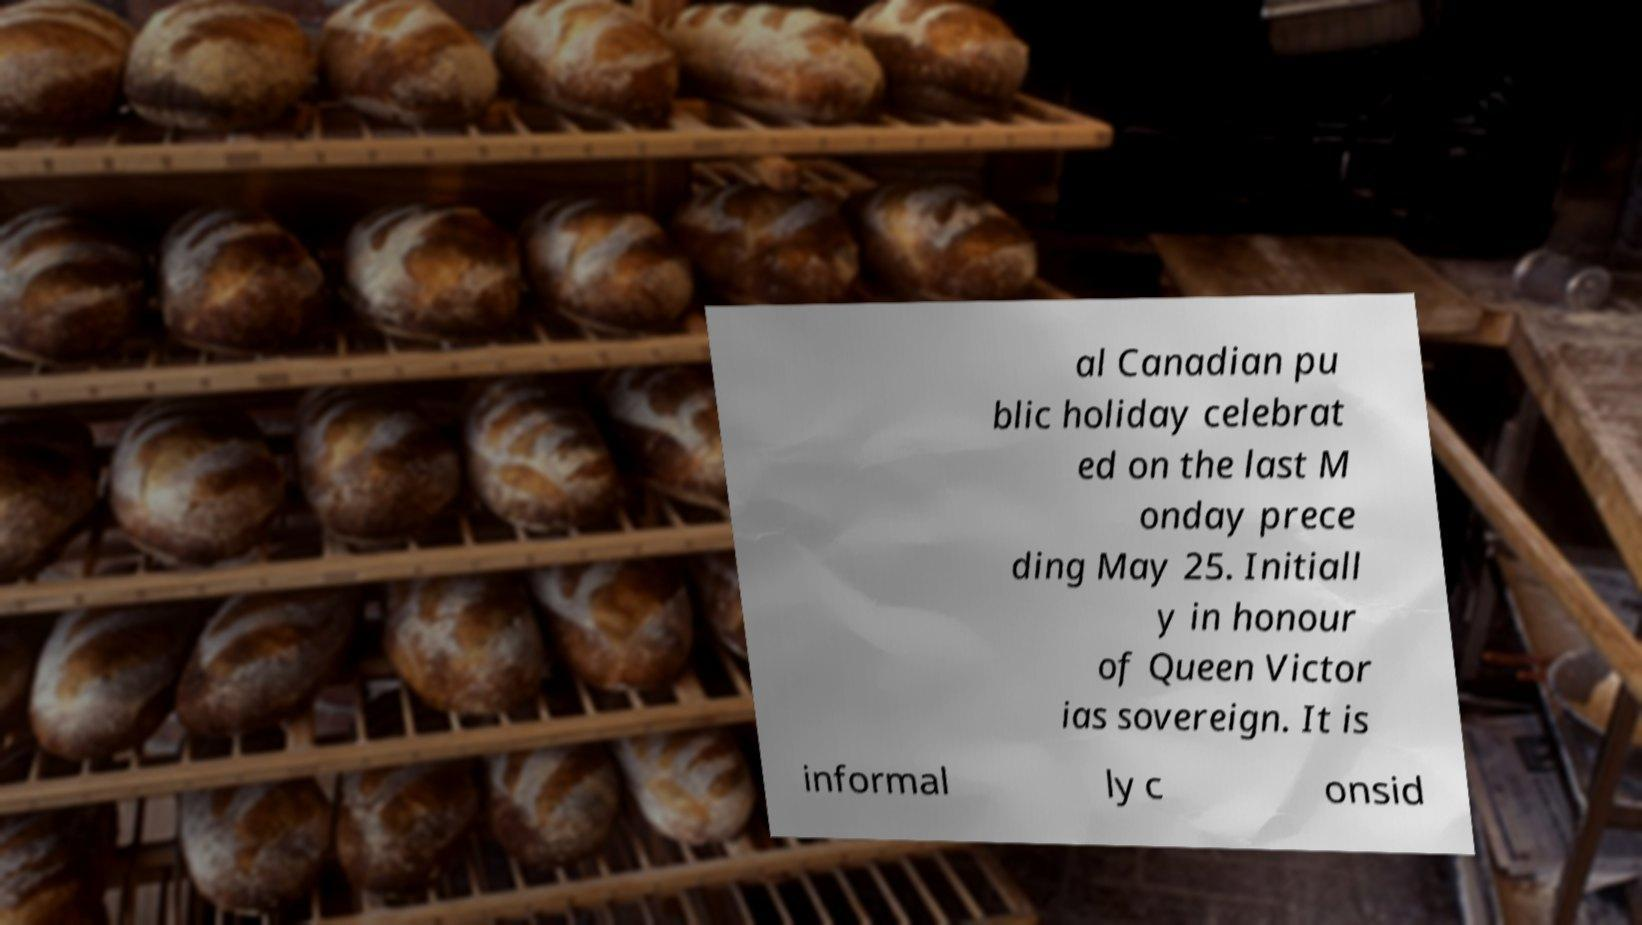Can you accurately transcribe the text from the provided image for me? al Canadian pu blic holiday celebrat ed on the last M onday prece ding May 25. Initiall y in honour of Queen Victor ias sovereign. It is informal ly c onsid 